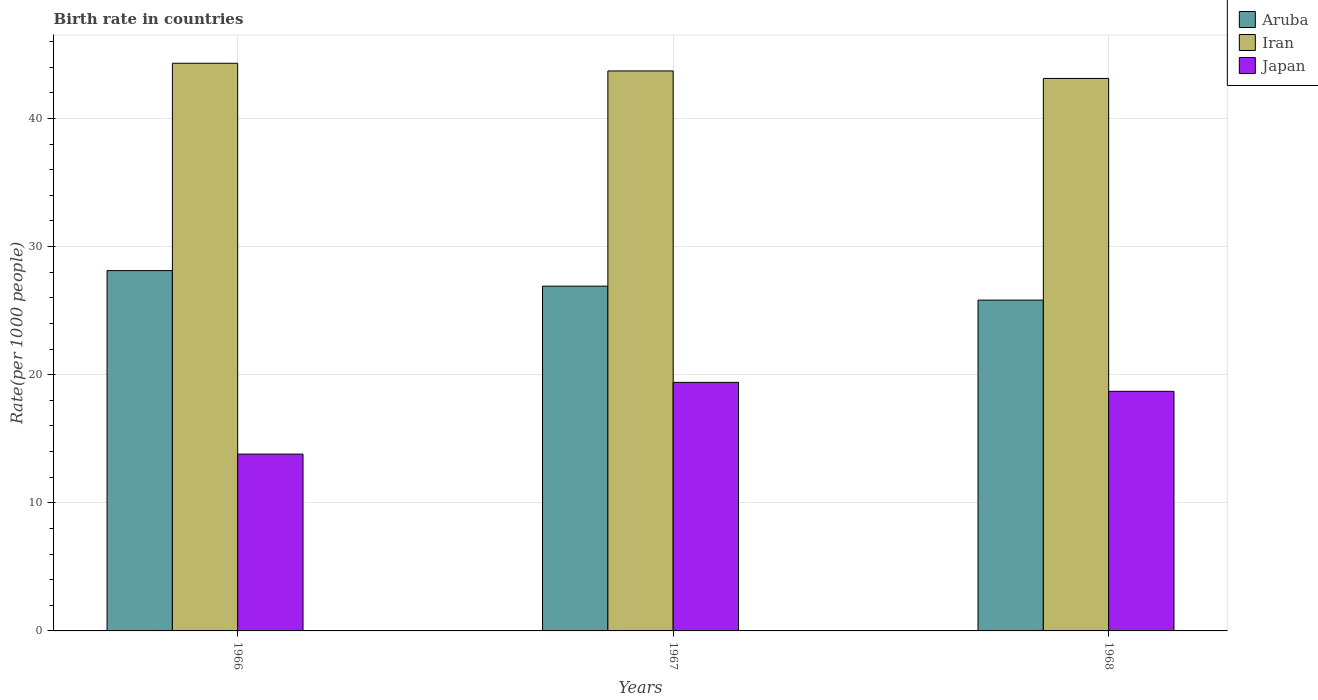Are the number of bars on each tick of the X-axis equal?
Offer a terse response. Yes. How many bars are there on the 3rd tick from the right?
Provide a succinct answer. 3. What is the label of the 2nd group of bars from the left?
Provide a short and direct response. 1967. What is the birth rate in Aruba in 1966?
Your answer should be very brief. 28.12. Across all years, what is the minimum birth rate in Iran?
Provide a short and direct response. 43.12. In which year was the birth rate in Aruba maximum?
Provide a short and direct response. 1966. In which year was the birth rate in Aruba minimum?
Offer a terse response. 1968. What is the total birth rate in Japan in the graph?
Ensure brevity in your answer.  51.9. What is the difference between the birth rate in Iran in 1967 and that in 1968?
Your answer should be compact. 0.58. What is the difference between the birth rate in Japan in 1966 and the birth rate in Iran in 1967?
Provide a succinct answer. -29.9. What is the average birth rate in Iran per year?
Make the answer very short. 43.71. In the year 1966, what is the difference between the birth rate in Iran and birth rate in Japan?
Your response must be concise. 30.5. What is the ratio of the birth rate in Aruba in 1967 to that in 1968?
Give a very brief answer. 1.04. Is the birth rate in Aruba in 1966 less than that in 1968?
Provide a short and direct response. No. What is the difference between the highest and the second highest birth rate in Iran?
Ensure brevity in your answer.  0.6. What is the difference between the highest and the lowest birth rate in Iran?
Offer a very short reply. 1.18. Is the sum of the birth rate in Japan in 1967 and 1968 greater than the maximum birth rate in Aruba across all years?
Your answer should be very brief. Yes. What does the 1st bar from the left in 1968 represents?
Offer a terse response. Aruba. What does the 3rd bar from the right in 1967 represents?
Give a very brief answer. Aruba. How many bars are there?
Give a very brief answer. 9. What is the difference between two consecutive major ticks on the Y-axis?
Provide a succinct answer. 10. What is the title of the graph?
Your response must be concise. Birth rate in countries. Does "Mauritius" appear as one of the legend labels in the graph?
Give a very brief answer. No. What is the label or title of the X-axis?
Your answer should be very brief. Years. What is the label or title of the Y-axis?
Your answer should be compact. Rate(per 1000 people). What is the Rate(per 1000 people) of Aruba in 1966?
Offer a very short reply. 28.12. What is the Rate(per 1000 people) of Iran in 1966?
Your answer should be very brief. 44.3. What is the Rate(per 1000 people) in Aruba in 1967?
Your response must be concise. 26.91. What is the Rate(per 1000 people) in Iran in 1967?
Ensure brevity in your answer.  43.7. What is the Rate(per 1000 people) in Aruba in 1968?
Make the answer very short. 25.82. What is the Rate(per 1000 people) in Iran in 1968?
Keep it short and to the point. 43.12. What is the Rate(per 1000 people) of Japan in 1968?
Keep it short and to the point. 18.7. Across all years, what is the maximum Rate(per 1000 people) in Aruba?
Ensure brevity in your answer.  28.12. Across all years, what is the maximum Rate(per 1000 people) of Iran?
Offer a very short reply. 44.3. Across all years, what is the minimum Rate(per 1000 people) in Aruba?
Keep it short and to the point. 25.82. Across all years, what is the minimum Rate(per 1000 people) of Iran?
Offer a terse response. 43.12. Across all years, what is the minimum Rate(per 1000 people) in Japan?
Keep it short and to the point. 13.8. What is the total Rate(per 1000 people) of Aruba in the graph?
Offer a terse response. 80.85. What is the total Rate(per 1000 people) in Iran in the graph?
Keep it short and to the point. 131.12. What is the total Rate(per 1000 people) in Japan in the graph?
Offer a terse response. 51.9. What is the difference between the Rate(per 1000 people) of Aruba in 1966 and that in 1967?
Your answer should be very brief. 1.21. What is the difference between the Rate(per 1000 people) in Iran in 1966 and that in 1967?
Provide a short and direct response. 0.6. What is the difference between the Rate(per 1000 people) of Japan in 1966 and that in 1967?
Keep it short and to the point. -5.6. What is the difference between the Rate(per 1000 people) of Aruba in 1966 and that in 1968?
Provide a succinct answer. 2.3. What is the difference between the Rate(per 1000 people) in Iran in 1966 and that in 1968?
Provide a short and direct response. 1.18. What is the difference between the Rate(per 1000 people) of Aruba in 1967 and that in 1968?
Your response must be concise. 1.09. What is the difference between the Rate(per 1000 people) in Iran in 1967 and that in 1968?
Provide a short and direct response. 0.58. What is the difference between the Rate(per 1000 people) of Aruba in 1966 and the Rate(per 1000 people) of Iran in 1967?
Your answer should be very brief. -15.58. What is the difference between the Rate(per 1000 people) of Aruba in 1966 and the Rate(per 1000 people) of Japan in 1967?
Give a very brief answer. 8.72. What is the difference between the Rate(per 1000 people) of Iran in 1966 and the Rate(per 1000 people) of Japan in 1967?
Give a very brief answer. 24.9. What is the difference between the Rate(per 1000 people) in Aruba in 1966 and the Rate(per 1000 people) in Iran in 1968?
Provide a succinct answer. -15. What is the difference between the Rate(per 1000 people) of Aruba in 1966 and the Rate(per 1000 people) of Japan in 1968?
Offer a very short reply. 9.42. What is the difference between the Rate(per 1000 people) in Iran in 1966 and the Rate(per 1000 people) in Japan in 1968?
Offer a very short reply. 25.6. What is the difference between the Rate(per 1000 people) of Aruba in 1967 and the Rate(per 1000 people) of Iran in 1968?
Keep it short and to the point. -16.21. What is the difference between the Rate(per 1000 people) in Aruba in 1967 and the Rate(per 1000 people) in Japan in 1968?
Provide a short and direct response. 8.21. What is the difference between the Rate(per 1000 people) in Iran in 1967 and the Rate(per 1000 people) in Japan in 1968?
Make the answer very short. 25. What is the average Rate(per 1000 people) of Aruba per year?
Make the answer very short. 26.95. What is the average Rate(per 1000 people) of Iran per year?
Offer a very short reply. 43.71. What is the average Rate(per 1000 people) of Japan per year?
Provide a short and direct response. 17.3. In the year 1966, what is the difference between the Rate(per 1000 people) of Aruba and Rate(per 1000 people) of Iran?
Offer a very short reply. -16.18. In the year 1966, what is the difference between the Rate(per 1000 people) in Aruba and Rate(per 1000 people) in Japan?
Your answer should be very brief. 14.32. In the year 1966, what is the difference between the Rate(per 1000 people) in Iran and Rate(per 1000 people) in Japan?
Provide a short and direct response. 30.5. In the year 1967, what is the difference between the Rate(per 1000 people) of Aruba and Rate(per 1000 people) of Iran?
Provide a succinct answer. -16.8. In the year 1967, what is the difference between the Rate(per 1000 people) of Aruba and Rate(per 1000 people) of Japan?
Ensure brevity in your answer.  7.51. In the year 1967, what is the difference between the Rate(per 1000 people) in Iran and Rate(per 1000 people) in Japan?
Your answer should be compact. 24.3. In the year 1968, what is the difference between the Rate(per 1000 people) in Aruba and Rate(per 1000 people) in Iran?
Offer a very short reply. -17.3. In the year 1968, what is the difference between the Rate(per 1000 people) in Aruba and Rate(per 1000 people) in Japan?
Keep it short and to the point. 7.12. In the year 1968, what is the difference between the Rate(per 1000 people) of Iran and Rate(per 1000 people) of Japan?
Ensure brevity in your answer.  24.42. What is the ratio of the Rate(per 1000 people) of Aruba in 1966 to that in 1967?
Your response must be concise. 1.05. What is the ratio of the Rate(per 1000 people) in Iran in 1966 to that in 1967?
Make the answer very short. 1.01. What is the ratio of the Rate(per 1000 people) of Japan in 1966 to that in 1967?
Offer a terse response. 0.71. What is the ratio of the Rate(per 1000 people) in Aruba in 1966 to that in 1968?
Provide a short and direct response. 1.09. What is the ratio of the Rate(per 1000 people) in Iran in 1966 to that in 1968?
Provide a succinct answer. 1.03. What is the ratio of the Rate(per 1000 people) in Japan in 1966 to that in 1968?
Your response must be concise. 0.74. What is the ratio of the Rate(per 1000 people) in Aruba in 1967 to that in 1968?
Offer a terse response. 1.04. What is the ratio of the Rate(per 1000 people) of Iran in 1967 to that in 1968?
Ensure brevity in your answer.  1.01. What is the ratio of the Rate(per 1000 people) of Japan in 1967 to that in 1968?
Make the answer very short. 1.04. What is the difference between the highest and the second highest Rate(per 1000 people) of Aruba?
Your response must be concise. 1.21. What is the difference between the highest and the second highest Rate(per 1000 people) of Japan?
Your response must be concise. 0.7. What is the difference between the highest and the lowest Rate(per 1000 people) of Aruba?
Your answer should be very brief. 2.3. What is the difference between the highest and the lowest Rate(per 1000 people) of Iran?
Your answer should be very brief. 1.18. What is the difference between the highest and the lowest Rate(per 1000 people) of Japan?
Your answer should be very brief. 5.6. 